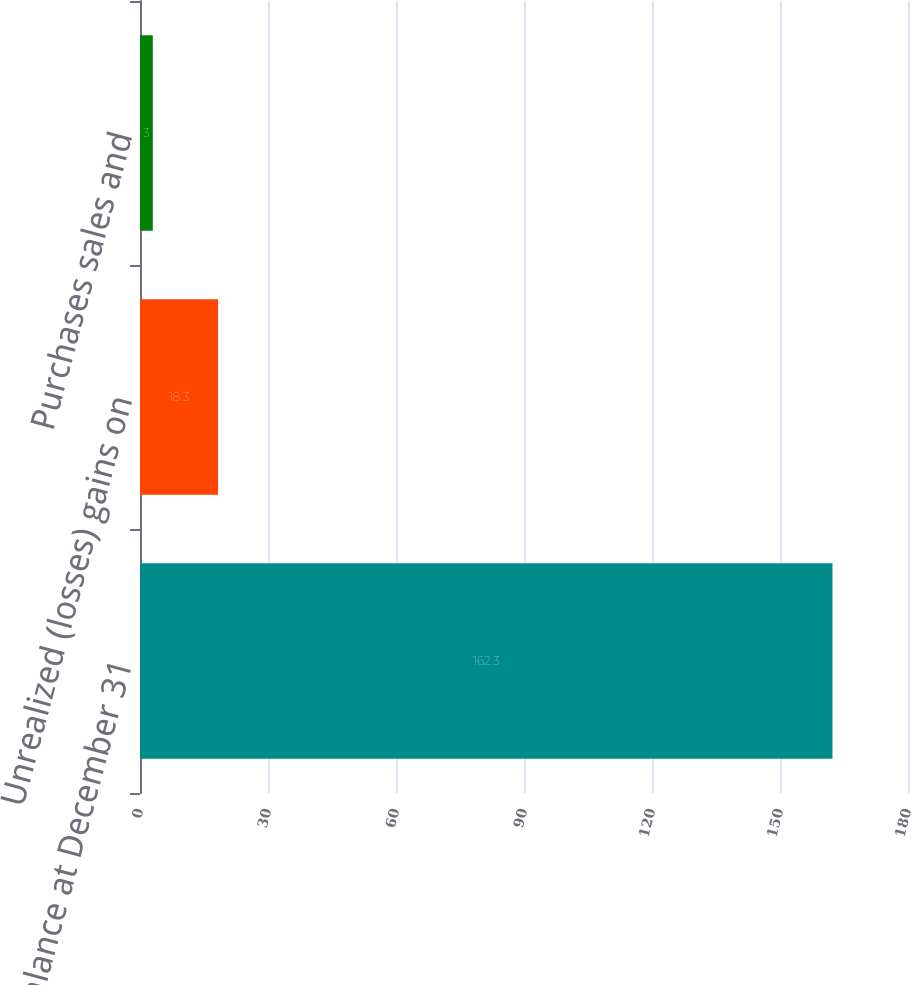Convert chart. <chart><loc_0><loc_0><loc_500><loc_500><bar_chart><fcel>Ending balance at December 31<fcel>Unrealized (losses) gains on<fcel>Purchases sales and<nl><fcel>162.3<fcel>18.3<fcel>3<nl></chart> 